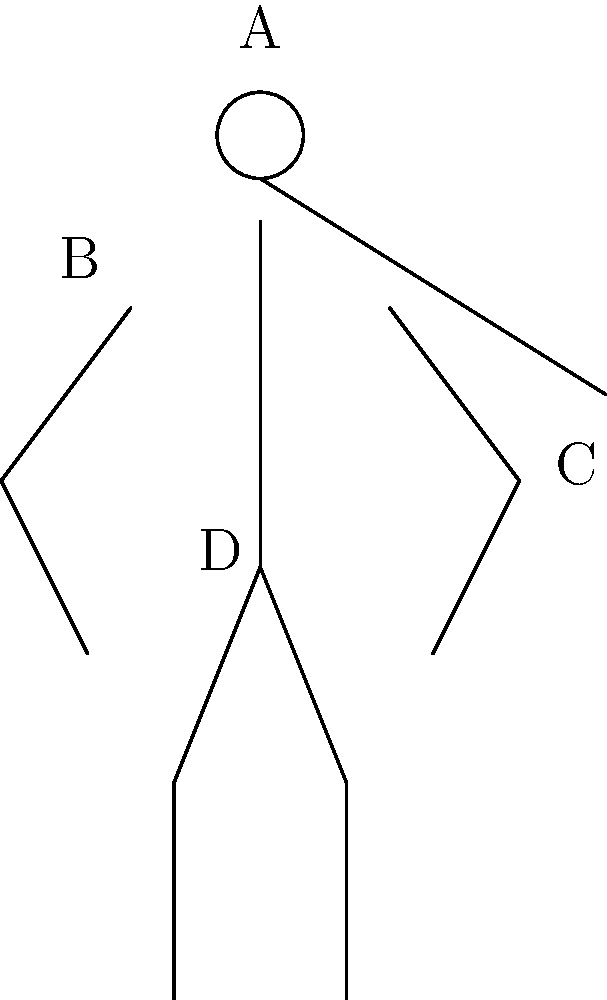In the stick figure illustration of proper trumpet playing posture, which labeled point represents the area where tension should be minimized to ensure optimal air flow and prevent fatigue during extended playing sessions? To determine the correct answer, let's analyze each labeled point and its significance in trumpet playing posture:

1. Point A: This represents the head position. While important for overall posture, it's not directly related to air flow or muscle tension affecting extended play.

2. Point B: This indicates the left shoulder area. Shoulder tension can affect playing, but it's not the most critical area for air flow.

3. Point C: This shows the right elbow position, which is important for holding the trumpet but doesn't directly impact air flow or cause significant fatigue during extended play.

4. Point D: This point represents the abdominal area, which is crucial for breath support and air flow in trumpet playing.

The area that should have minimal tension to ensure optimal air flow and prevent fatigue during extended playing sessions is the abdominal region. This area, represented by point D, is vital for proper breath support and control.

Keeping the abdominal muscles relaxed allows for:
1. Deeper, more efficient breathing
2. Better control of air flow
3. Reduced tension in the upper body
4. Improved endurance during long playing sessions

By maintaining a relaxed abdominal area, trumpet players can achieve better tone, more consistent air support, and reduced fatigue during extended performances.
Answer: D (abdominal area) 